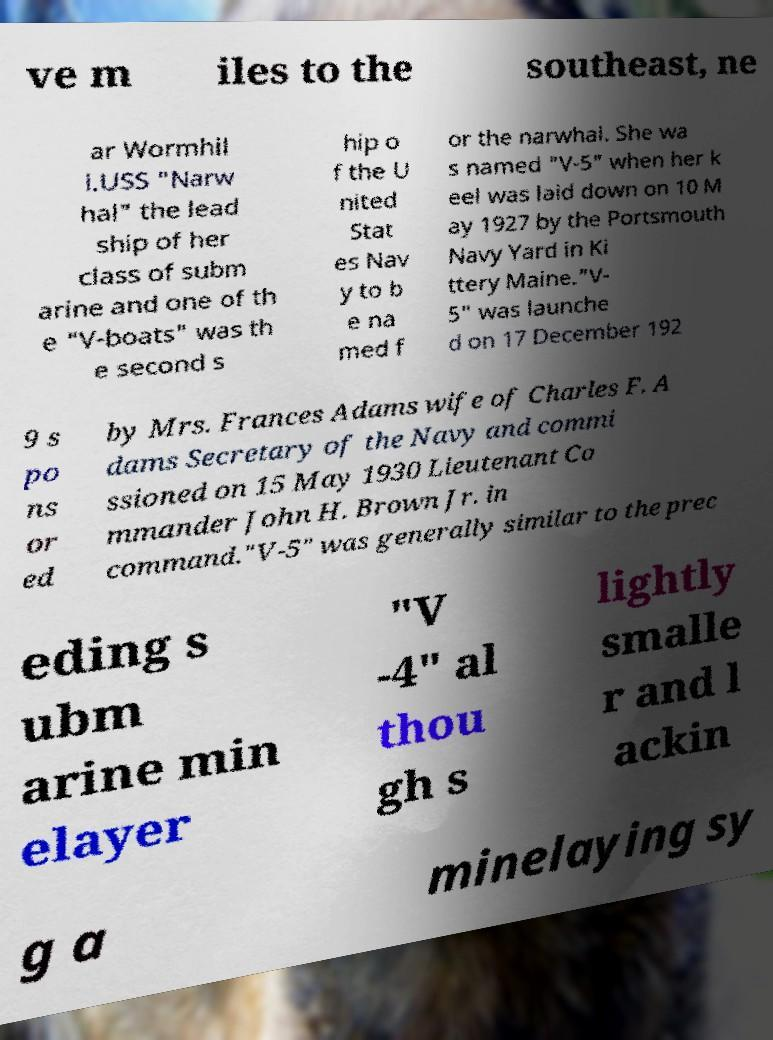Please read and relay the text visible in this image. What does it say? ve m iles to the southeast, ne ar Wormhil l.USS "Narw hal" the lead ship of her class of subm arine and one of th e "V-boats" was th e second s hip o f the U nited Stat es Nav y to b e na med f or the narwhal. She wa s named "V-5" when her k eel was laid down on 10 M ay 1927 by the Portsmouth Navy Yard in Ki ttery Maine."V- 5" was launche d on 17 December 192 9 s po ns or ed by Mrs. Frances Adams wife of Charles F. A dams Secretary of the Navy and commi ssioned on 15 May 1930 Lieutenant Co mmander John H. Brown Jr. in command."V-5" was generally similar to the prec eding s ubm arine min elayer "V -4" al thou gh s lightly smalle r and l ackin g a minelaying sy 